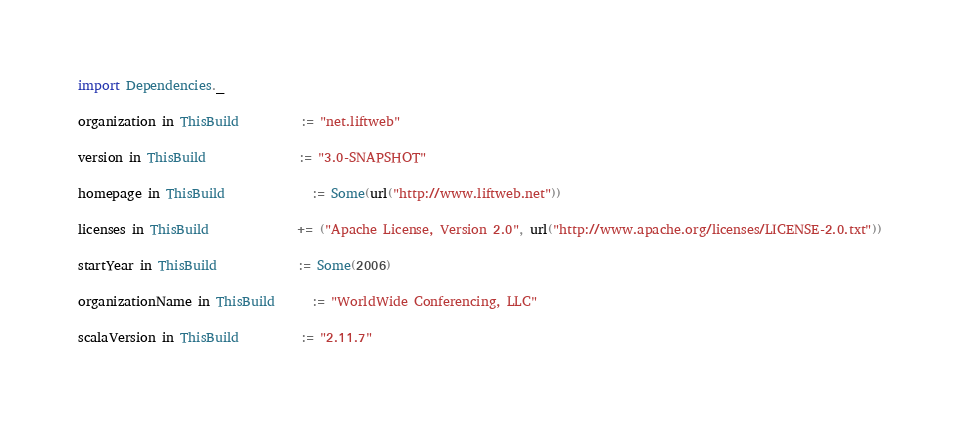<code> <loc_0><loc_0><loc_500><loc_500><_Scala_>import Dependencies._

organization in ThisBuild          := "net.liftweb"

version in ThisBuild               := "3.0-SNAPSHOT"

homepage in ThisBuild              := Some(url("http://www.liftweb.net"))

licenses in ThisBuild              += ("Apache License, Version 2.0", url("http://www.apache.org/licenses/LICENSE-2.0.txt"))

startYear in ThisBuild             := Some(2006)

organizationName in ThisBuild      := "WorldWide Conferencing, LLC"

scalaVersion in ThisBuild          := "2.11.7"
</code> 